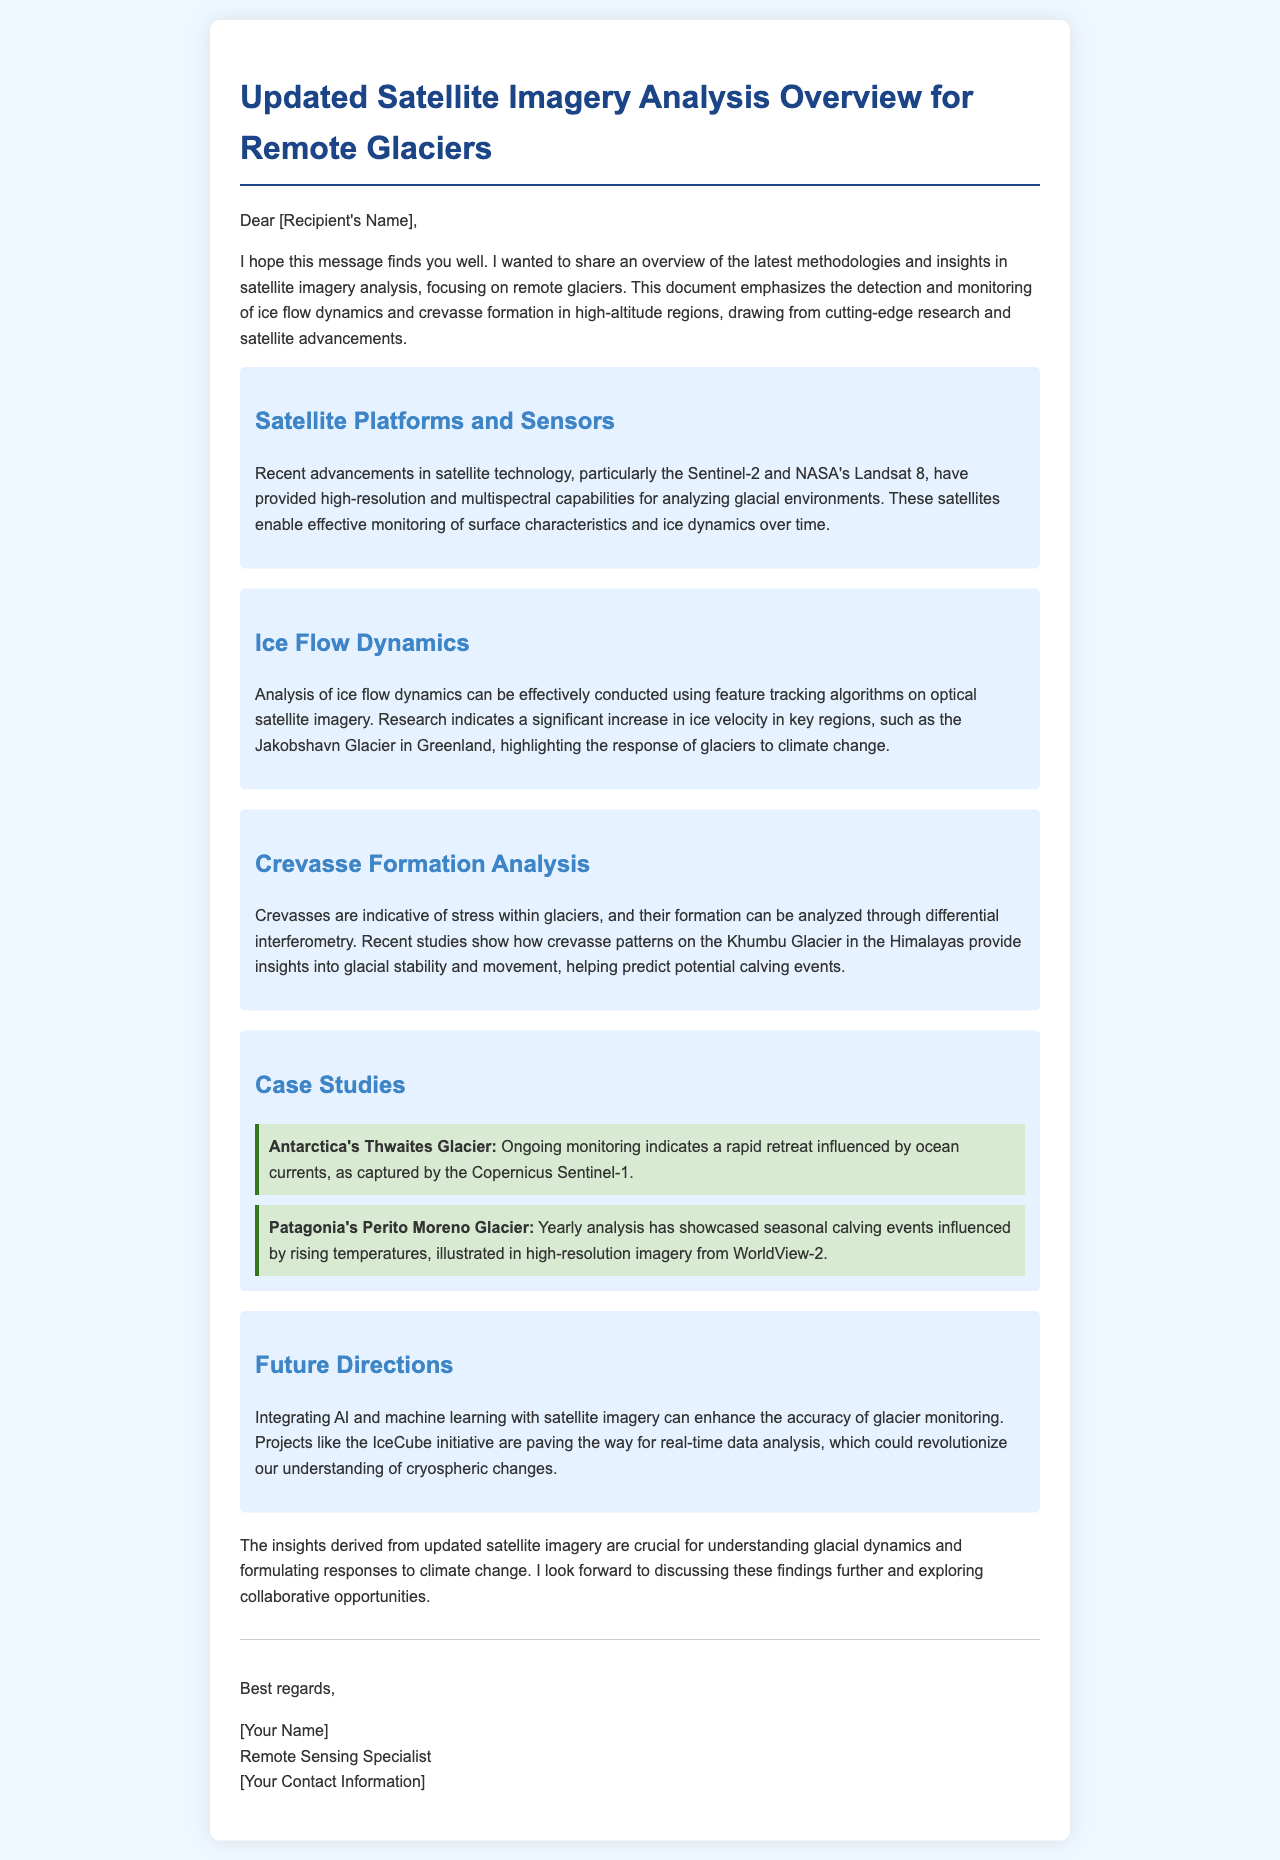what are the satellite platforms mentioned? The document highlights Sentinel-2 and NASA's Landsat 8 as the satellite platforms used for glacial analysis.
Answer: Sentinel-2 and NASA's Landsat 8 what is the focus of the ice flow dynamics section? The focus is on analyzing ice flow dynamics using feature tracking algorithms on optical satellite imagery.
Answer: Feature tracking algorithms which glacier is highlighted for significant ice velocity increase? Jakobshavn Glacier is noted for a significant increase in ice velocity due to climate change.
Answer: Jakobshavn Glacier what analytical method is used for crevasse formation analysis? The method mentioned for analyzing crevasse formation is differential interferometry.
Answer: Differential interferometry which glacier in Antarctica is monitored for rapid retreat? Thwaites Glacier in Antarctica is indicated as undergoing rapid retreat influenced by ocean currents.
Answer: Thwaites Glacier what technological integration is suggested for future directions in glacier monitoring? The document suggests the integration of AI and machine learning for enhancing glacier monitoring accuracy.
Answer: AI and machine learning how does the Perito Moreno Glacier react seasonally? The Perito Moreno Glacier showcases seasonal calving events influenced by rising temperatures.
Answer: Seasonal calving events what initiative is mentioned for real-time data analysis? The IceCube initiative is mentioned as paving the way for real-time data analysis in glacier monitoring.
Answer: IceCube initiative 